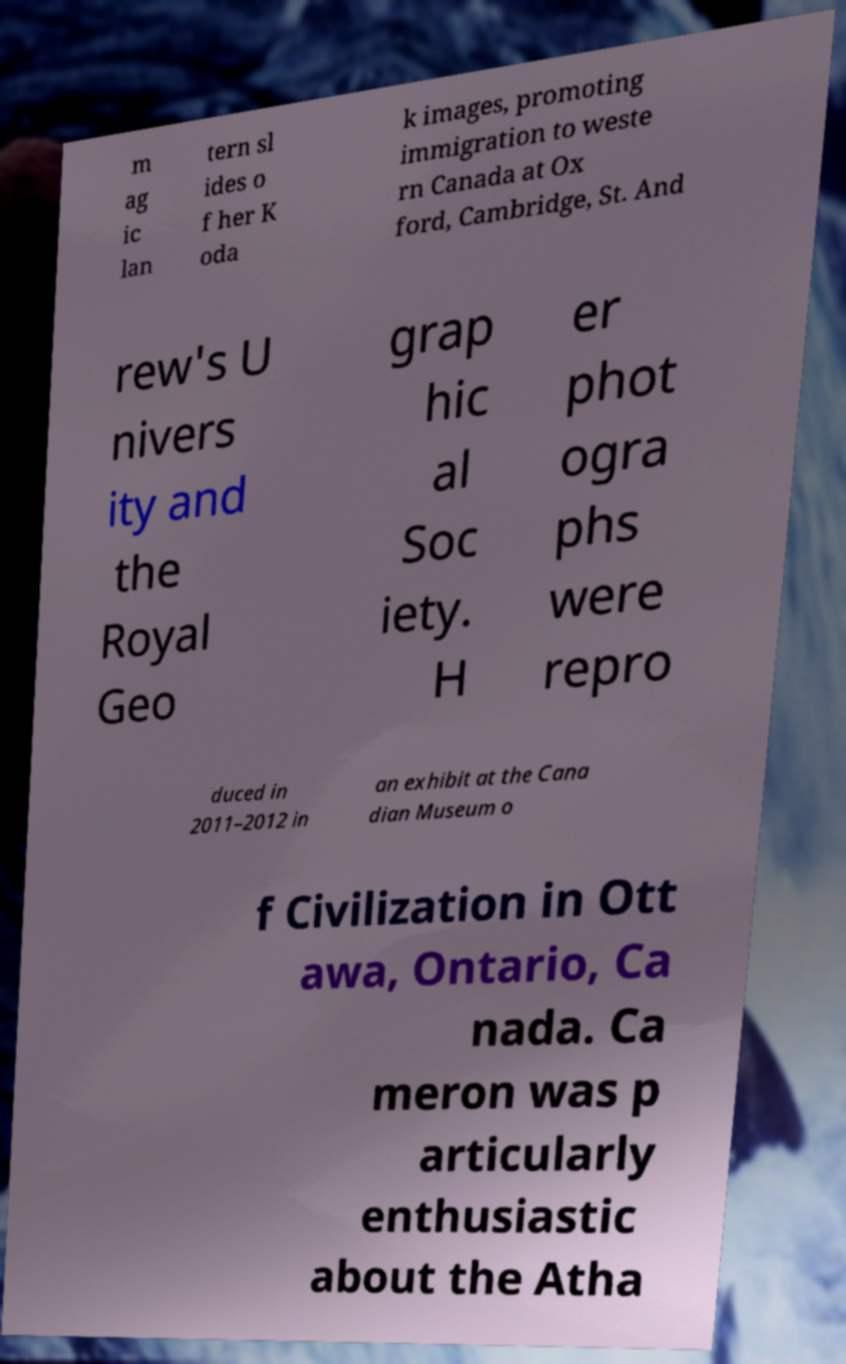Please read and relay the text visible in this image. What does it say? m ag ic lan tern sl ides o f her K oda k images, promoting immigration to weste rn Canada at Ox ford, Cambridge, St. And rew's U nivers ity and the Royal Geo grap hic al Soc iety. H er phot ogra phs were repro duced in 2011–2012 in an exhibit at the Cana dian Museum o f Civilization in Ott awa, Ontario, Ca nada. Ca meron was p articularly enthusiastic about the Atha 